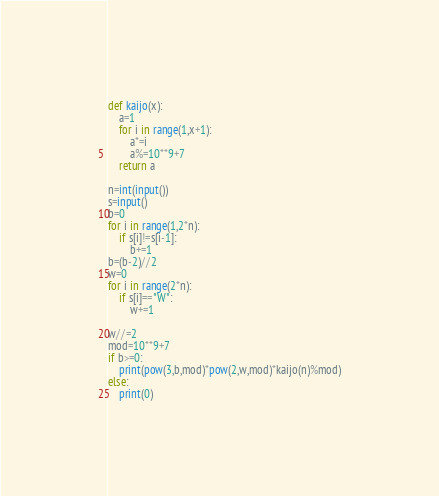<code> <loc_0><loc_0><loc_500><loc_500><_Python_>def kaijo(x):
	a=1
	for i in range(1,x+1):
		a*=i
		a%=10**9+7
	return a

n=int(input())
s=input()
b=0
for i in range(1,2*n):
	if s[i]!=s[i-1]:
		b+=1
b=(b-2)//2
w=0
for i in range(2*n):
	if s[i]=="W":
		w+=1

w//=2
mod=10**9+7
if b>=0:
	print(pow(3,b,mod)*pow(2,w,mod)*kaijo(n)%mod)
else:
	print(0)</code> 